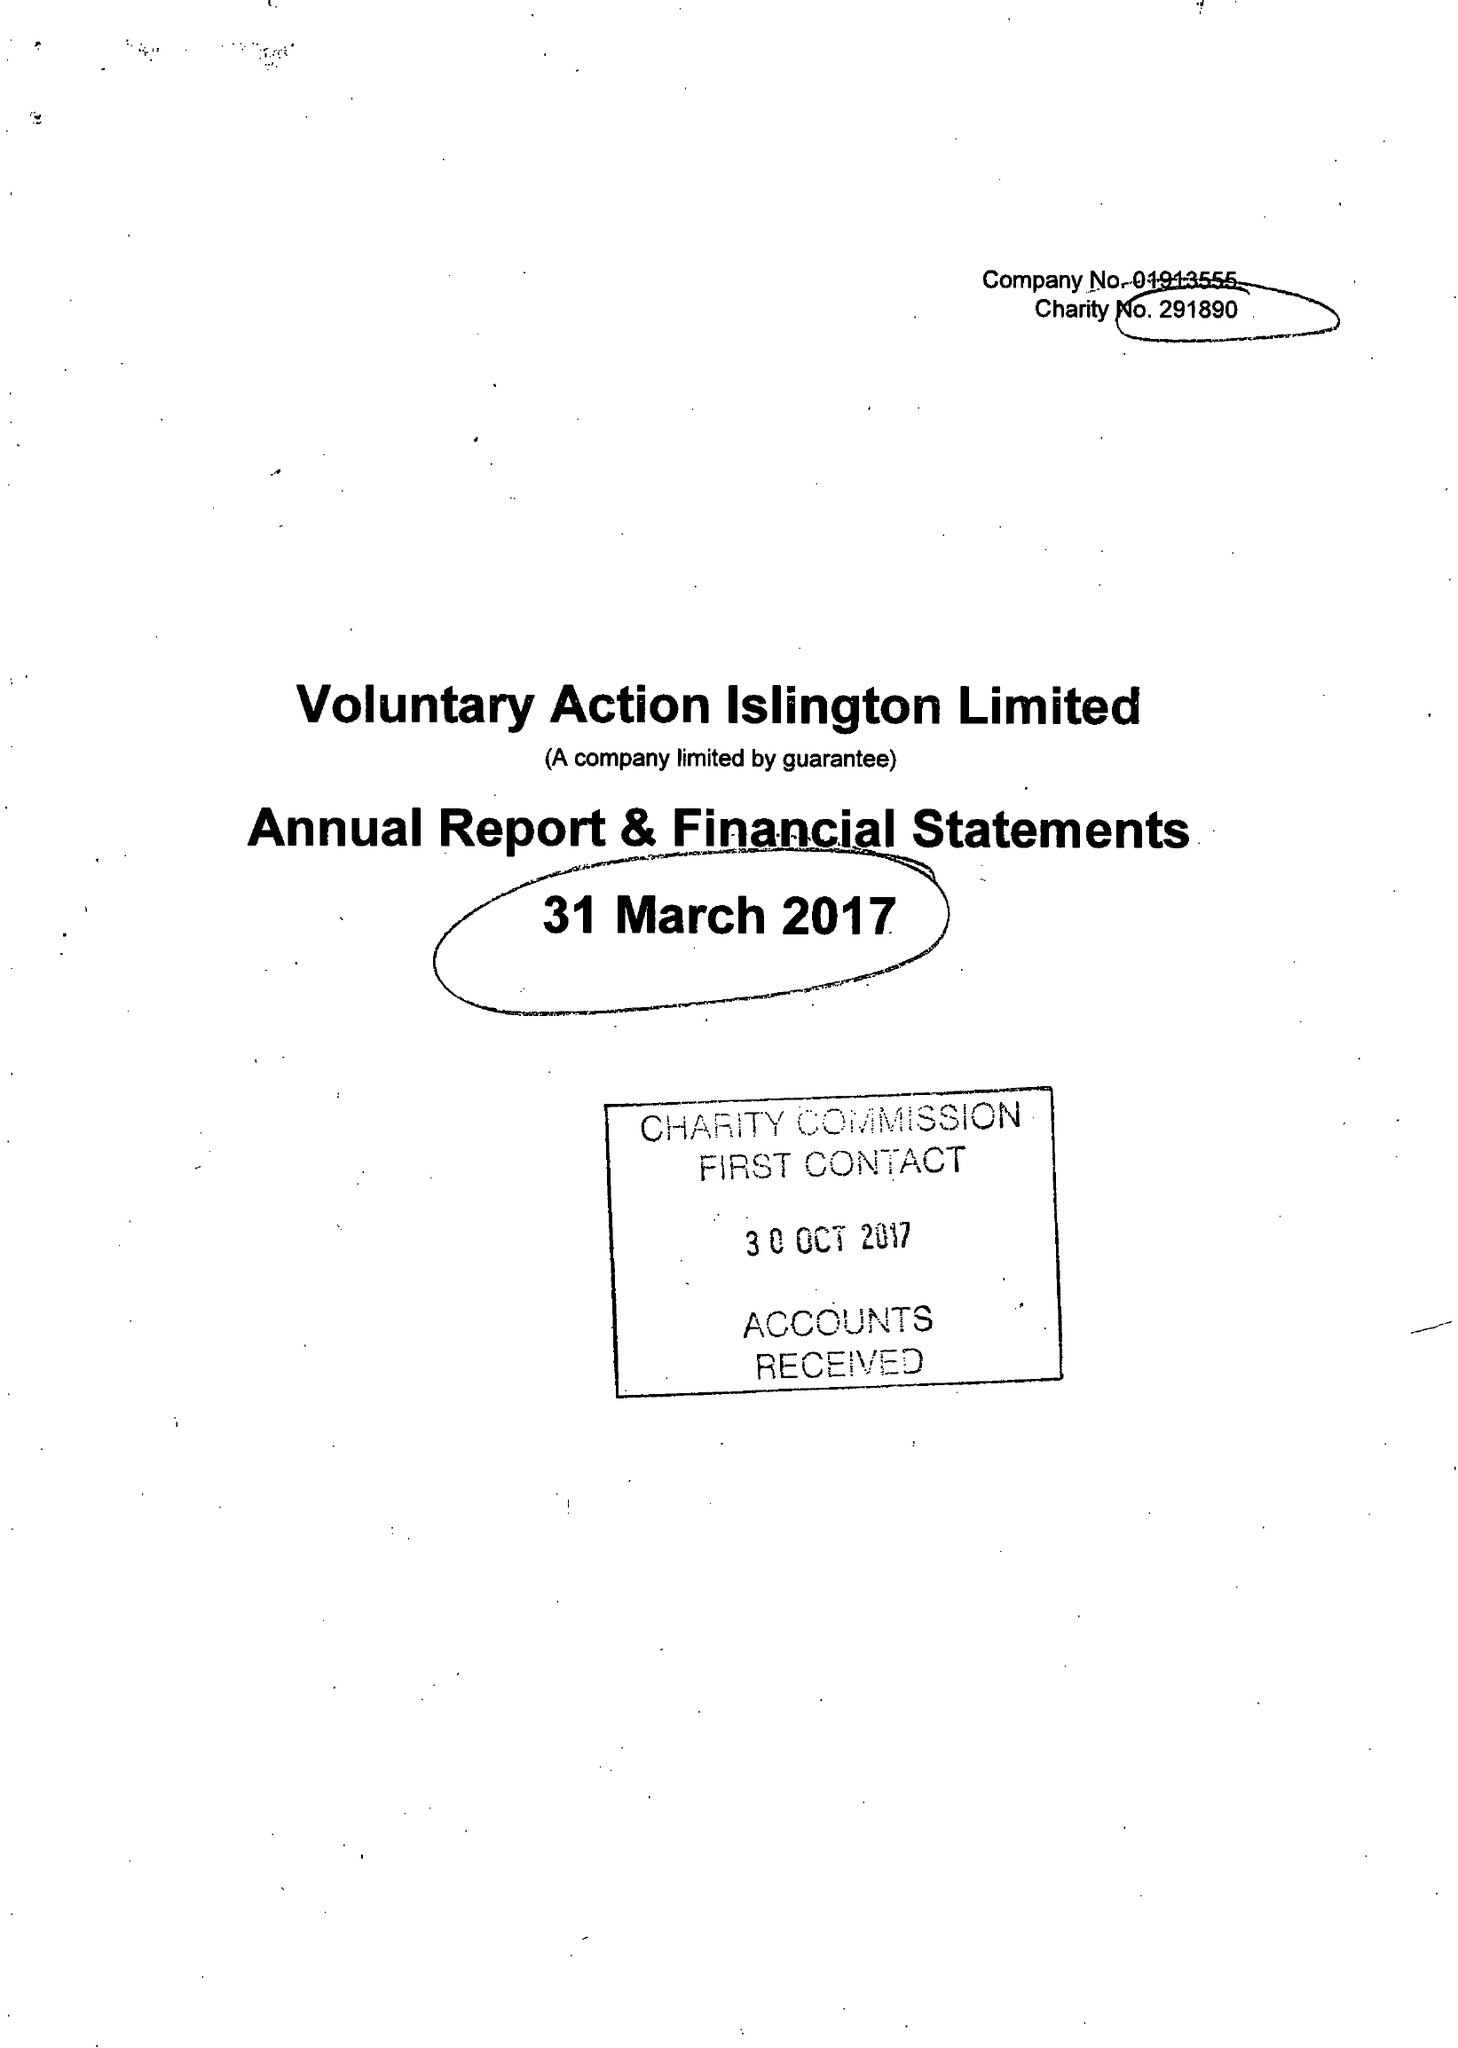What is the value for the income_annually_in_british_pounds?
Answer the question using a single word or phrase. 394888.00 